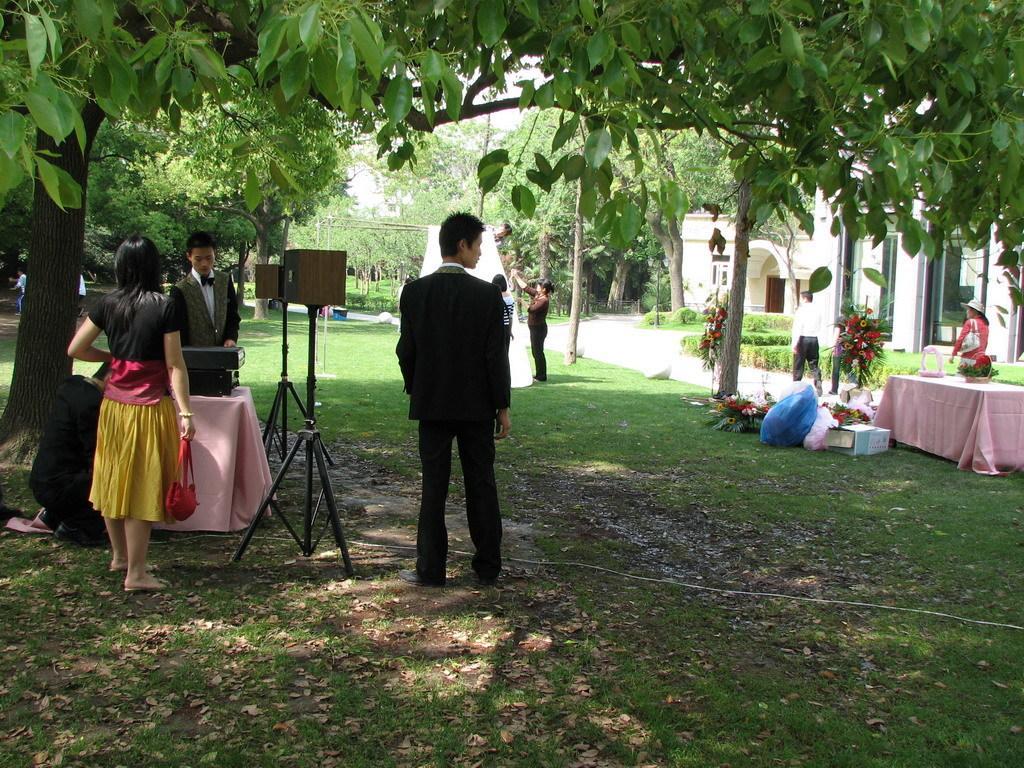How would you summarize this image in a sentence or two? In this image I can see few people. On the table there is a flower pot. At the back side there are trees and a building. 